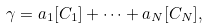Convert formula to latex. <formula><loc_0><loc_0><loc_500><loc_500>\gamma = a _ { 1 } [ C _ { 1 } ] + \cdots + a _ { N } [ C _ { N } ] ,</formula> 